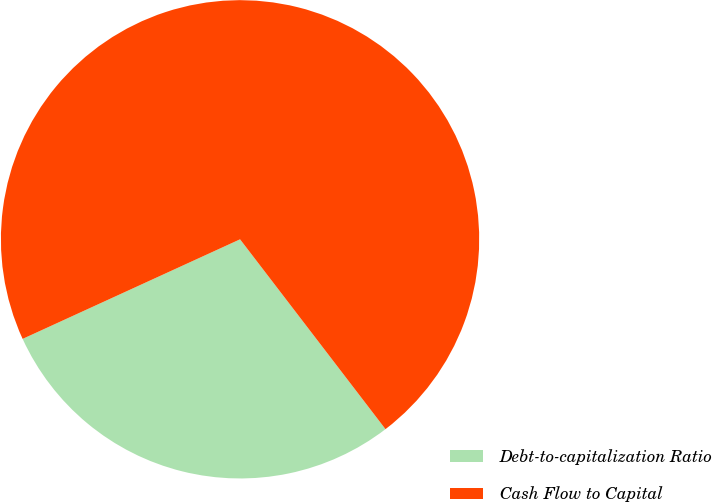<chart> <loc_0><loc_0><loc_500><loc_500><pie_chart><fcel>Debt-to-capitalization Ratio<fcel>Cash Flow to Capital<nl><fcel>28.57%<fcel>71.43%<nl></chart> 